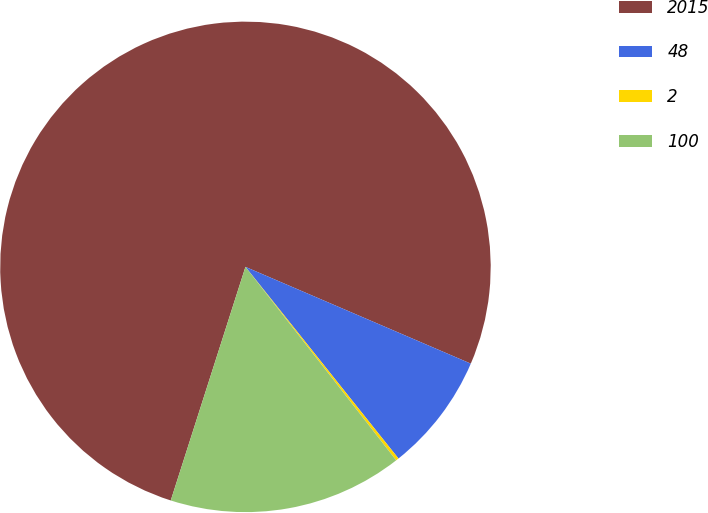<chart> <loc_0><loc_0><loc_500><loc_500><pie_chart><fcel>2015<fcel>48<fcel>2<fcel>100<nl><fcel>76.53%<fcel>7.82%<fcel>0.19%<fcel>15.46%<nl></chart> 